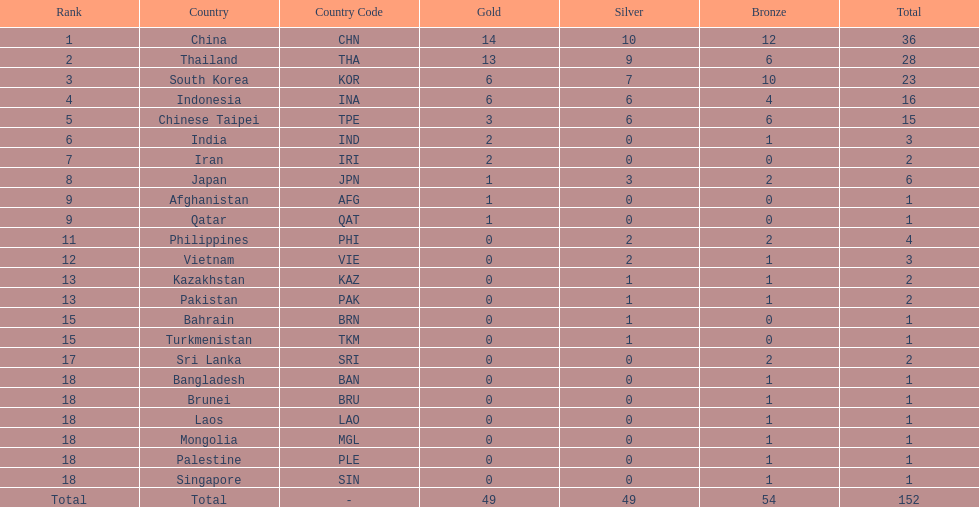How many nations received a medal in each gold, silver, and bronze? 6. 